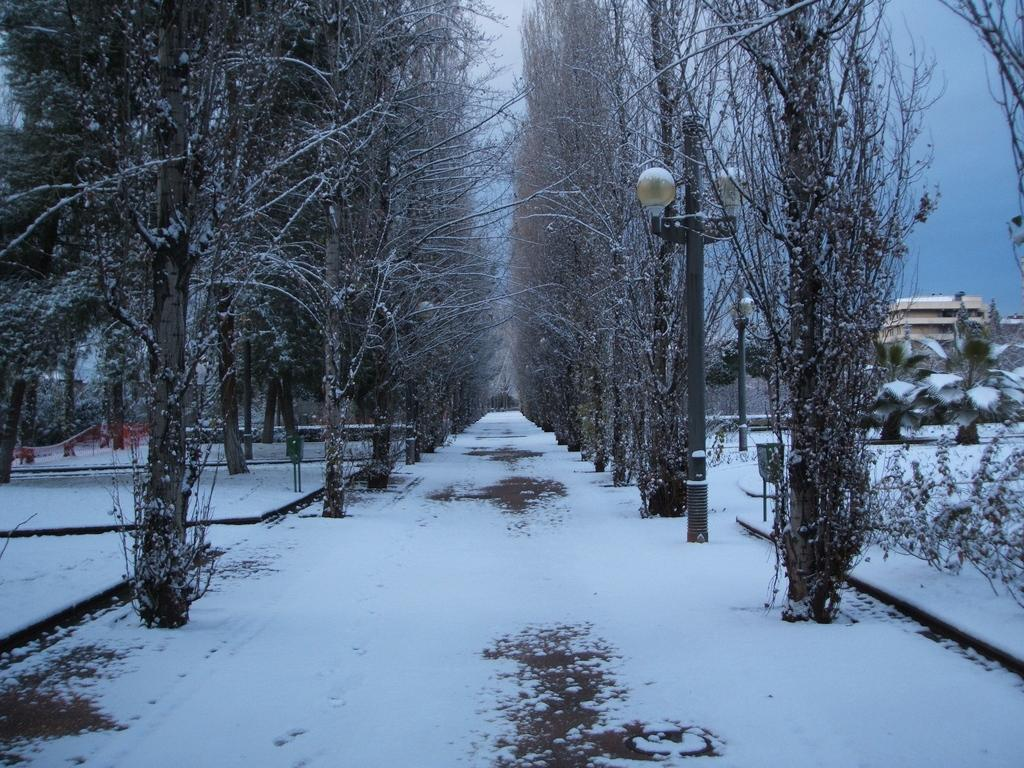What is covering the road in the image? There is snow on the road. What is the condition of the trees in the image? The trees are covered with snow on either side of the road. What type of learning is taking place in the image? There is no indication of learning in the image; it primarily features snow-covered trees and a road. What kind of drug can be seen in the image? There is no drug present in the image; it is a scene of snow-covered trees and a road. 